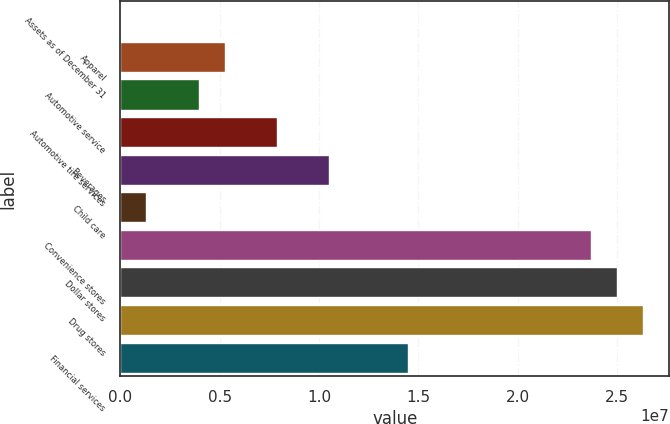<chart> <loc_0><loc_0><loc_500><loc_500><bar_chart><fcel>Assets as of December 31<fcel>Apparel<fcel>Automotive service<fcel>Automotive tire services<fcel>Beverages<fcel>Child care<fcel>Convenience stores<fcel>Dollar stores<fcel>Drug stores<fcel>Financial services<nl><fcel>2016<fcel>5.26236e+06<fcel>3.94727e+06<fcel>7.89253e+06<fcel>1.05227e+07<fcel>1.3171e+06<fcel>2.36736e+07<fcel>2.49886e+07<fcel>2.63037e+07<fcel>1.4468e+07<nl></chart> 